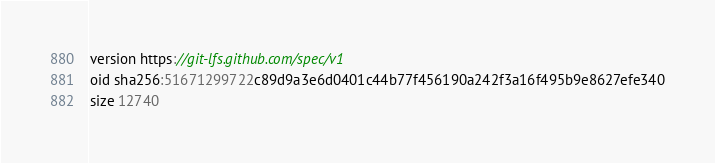Convert code to text. <code><loc_0><loc_0><loc_500><loc_500><_C_>version https://git-lfs.github.com/spec/v1
oid sha256:51671299722c89d9a3e6d0401c44b77f456190a242f3a16f495b9e8627efe340
size 12740
</code> 